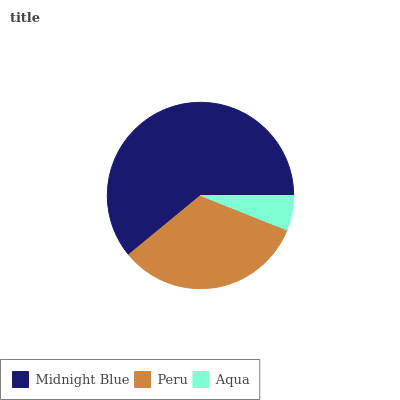Is Aqua the minimum?
Answer yes or no. Yes. Is Midnight Blue the maximum?
Answer yes or no. Yes. Is Peru the minimum?
Answer yes or no. No. Is Peru the maximum?
Answer yes or no. No. Is Midnight Blue greater than Peru?
Answer yes or no. Yes. Is Peru less than Midnight Blue?
Answer yes or no. Yes. Is Peru greater than Midnight Blue?
Answer yes or no. No. Is Midnight Blue less than Peru?
Answer yes or no. No. Is Peru the high median?
Answer yes or no. Yes. Is Peru the low median?
Answer yes or no. Yes. Is Aqua the high median?
Answer yes or no. No. Is Midnight Blue the low median?
Answer yes or no. No. 